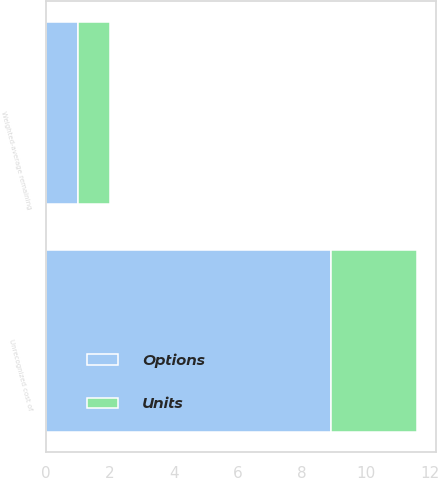Convert chart. <chart><loc_0><loc_0><loc_500><loc_500><stacked_bar_chart><ecel><fcel>Unrecognized cost of<fcel>Weighted-average remaining<nl><fcel>Units<fcel>2.7<fcel>1<nl><fcel>Options<fcel>8.9<fcel>1<nl></chart> 